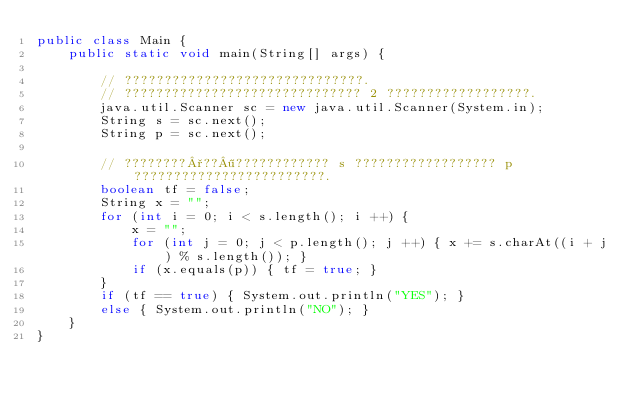<code> <loc_0><loc_0><loc_500><loc_500><_Java_>public class Main {
    public static void main(String[] args) {

        // ??????????????????????????????.
        // ?????????????????????????????? 2 ??????????????????.
        java.util.Scanner sc = new java.util.Scanner(System.in);
        String s = sc.next();
        String p = sc.next();

        // ????????°??¶???????????? s ?????????????????? p ????????????????????????.
        boolean tf = false;
        String x = "";
        for (int i = 0; i < s.length(); i ++) {
            x = "";
            for (int j = 0; j < p.length(); j ++) { x += s.charAt((i + j) % s.length()); }
            if (x.equals(p)) { tf = true; }
        }
        if (tf == true) { System.out.println("YES"); }
        else { System.out.println("NO"); }
    }
}</code> 